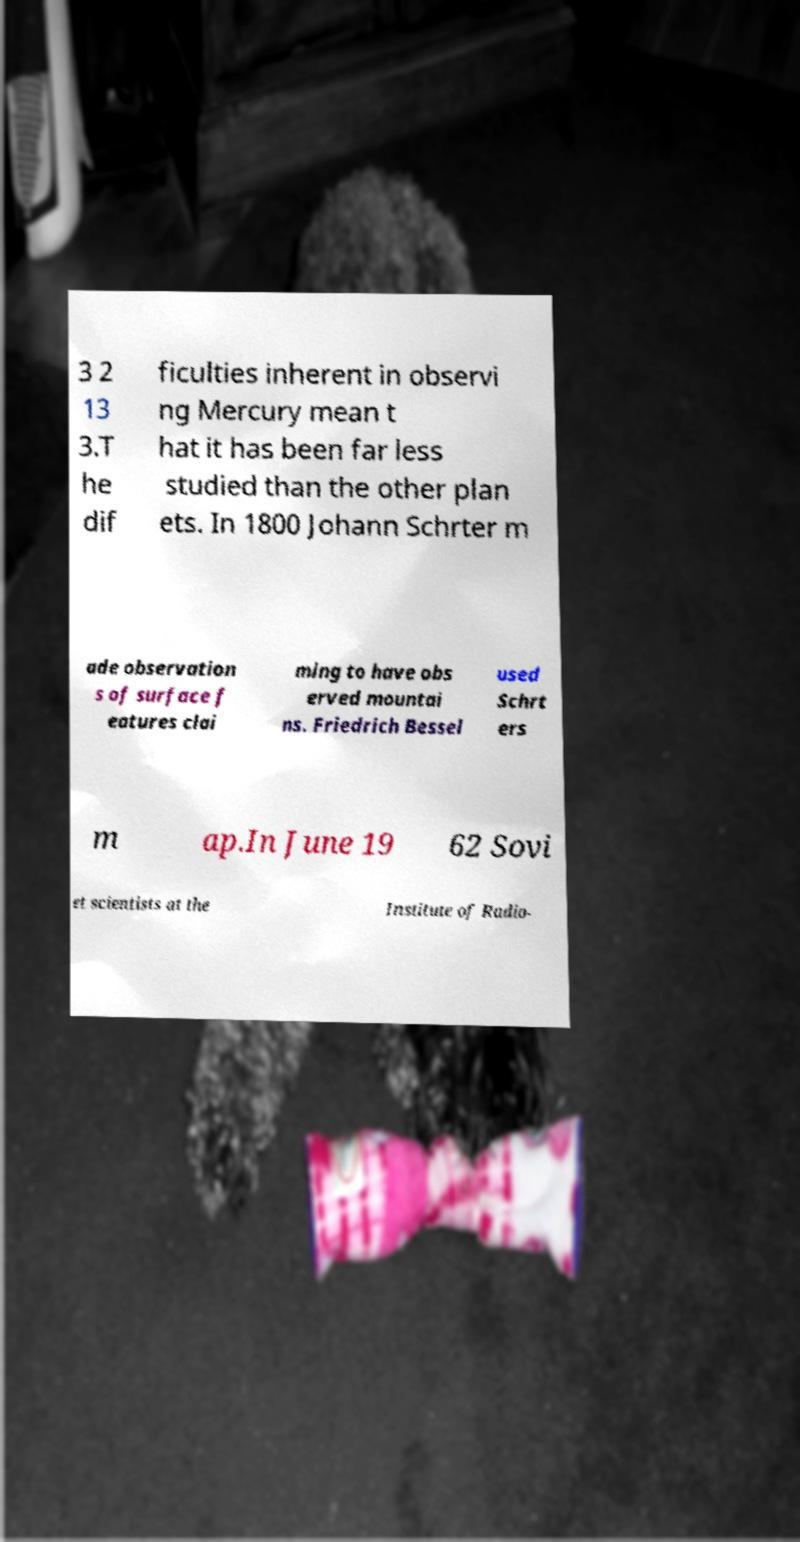I need the written content from this picture converted into text. Can you do that? 3 2 13 3.T he dif ficulties inherent in observi ng Mercury mean t hat it has been far less studied than the other plan ets. In 1800 Johann Schrter m ade observation s of surface f eatures clai ming to have obs erved mountai ns. Friedrich Bessel used Schrt ers m ap.In June 19 62 Sovi et scientists at the Institute of Radio- 